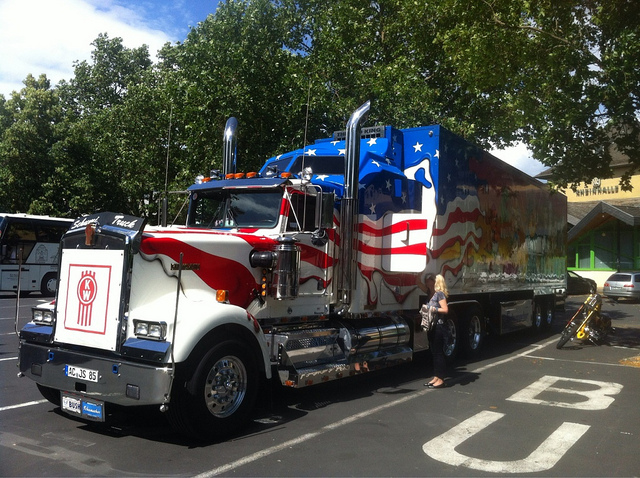Please transcribe the text in this image. 85 BU 